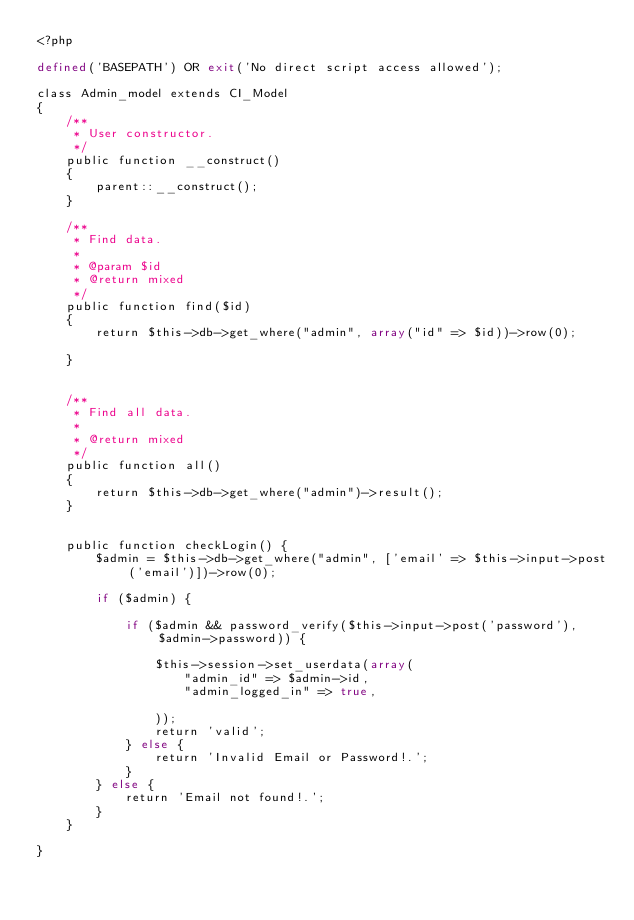Convert code to text. <code><loc_0><loc_0><loc_500><loc_500><_PHP_><?php

defined('BASEPATH') OR exit('No direct script access allowed');

class Admin_model extends CI_Model
{
    /**
     * User constructor.
     */
    public function __construct()
    {
        parent::__construct();
    }

    /**
     * Find data.
     *
     * @param $id
     * @return mixed
     */
    public function find($id)
    {
        return $this->db->get_where("admin", array("id" => $id))->row(0);
        
    }
    

    /**
     * Find all data.
     *
     * @return mixed
     */
    public function all()
    {
        return $this->db->get_where("admin")->result();
    }

   
    public function checkLogin() {    
        $admin = $this->db->get_where("admin", ['email' => $this->input->post('email')])->row(0);
         
        if ($admin) {
            
            if ($admin && password_verify($this->input->post('password'), $admin->password)) {
                            
                $this->session->set_userdata(array(
                    "admin_id" => $admin->id,                   
                    "admin_logged_in" => true,
                    
                ));
                return 'valid';
            } else {               
                return 'Invalid Email or Password!.';
            }
        } else {
            return 'Email not found!.';
        }
    }

}</code> 